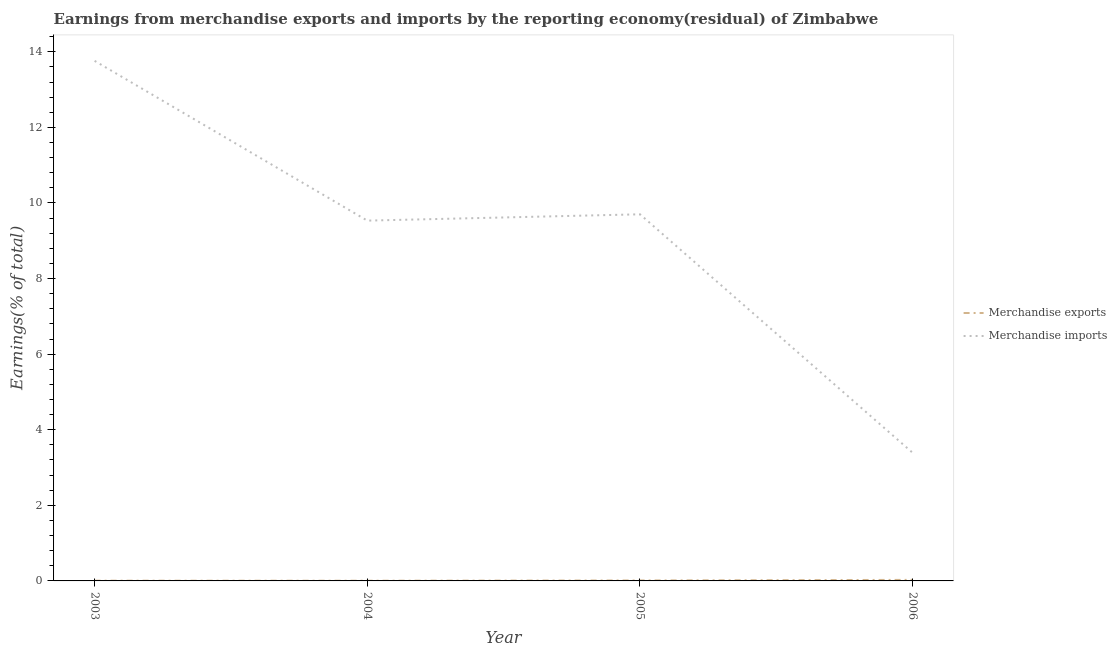How many different coloured lines are there?
Offer a very short reply. 2. Does the line corresponding to earnings from merchandise exports intersect with the line corresponding to earnings from merchandise imports?
Make the answer very short. No. Is the number of lines equal to the number of legend labels?
Your answer should be compact. Yes. What is the earnings from merchandise imports in 2005?
Give a very brief answer. 9.7. Across all years, what is the maximum earnings from merchandise exports?
Offer a very short reply. 0.03. Across all years, what is the minimum earnings from merchandise imports?
Offer a very short reply. 3.39. In which year was the earnings from merchandise imports maximum?
Make the answer very short. 2003. In which year was the earnings from merchandise imports minimum?
Provide a succinct answer. 2006. What is the total earnings from merchandise imports in the graph?
Make the answer very short. 36.38. What is the difference between the earnings from merchandise imports in 2005 and that in 2006?
Your answer should be very brief. 6.31. What is the difference between the earnings from merchandise exports in 2006 and the earnings from merchandise imports in 2005?
Ensure brevity in your answer.  -9.67. What is the average earnings from merchandise imports per year?
Offer a very short reply. 9.1. In the year 2005, what is the difference between the earnings from merchandise exports and earnings from merchandise imports?
Provide a short and direct response. -9.69. In how many years, is the earnings from merchandise exports greater than 4.8 %?
Give a very brief answer. 0. What is the ratio of the earnings from merchandise exports in 2005 to that in 2006?
Ensure brevity in your answer.  0.44. Is the earnings from merchandise exports in 2005 less than that in 2006?
Give a very brief answer. Yes. Is the difference between the earnings from merchandise exports in 2003 and 2006 greater than the difference between the earnings from merchandise imports in 2003 and 2006?
Your answer should be compact. No. What is the difference between the highest and the second highest earnings from merchandise imports?
Your answer should be compact. 4.06. What is the difference between the highest and the lowest earnings from merchandise exports?
Provide a succinct answer. 0.02. Is the sum of the earnings from merchandise exports in 2003 and 2006 greater than the maximum earnings from merchandise imports across all years?
Offer a very short reply. No. Does the earnings from merchandise exports monotonically increase over the years?
Ensure brevity in your answer.  No. Is the earnings from merchandise imports strictly greater than the earnings from merchandise exports over the years?
Keep it short and to the point. Yes. Is the earnings from merchandise exports strictly less than the earnings from merchandise imports over the years?
Your answer should be compact. Yes. What is the difference between two consecutive major ticks on the Y-axis?
Provide a short and direct response. 2. Are the values on the major ticks of Y-axis written in scientific E-notation?
Your response must be concise. No. Does the graph contain grids?
Your response must be concise. No. Where does the legend appear in the graph?
Your response must be concise. Center right. How are the legend labels stacked?
Offer a very short reply. Vertical. What is the title of the graph?
Give a very brief answer. Earnings from merchandise exports and imports by the reporting economy(residual) of Zimbabwe. Does "Unregistered firms" appear as one of the legend labels in the graph?
Your answer should be compact. No. What is the label or title of the Y-axis?
Your answer should be very brief. Earnings(% of total). What is the Earnings(% of total) of Merchandise exports in 2003?
Give a very brief answer. 0.01. What is the Earnings(% of total) in Merchandise imports in 2003?
Provide a succinct answer. 13.76. What is the Earnings(% of total) in Merchandise exports in 2004?
Ensure brevity in your answer.  0.01. What is the Earnings(% of total) of Merchandise imports in 2004?
Give a very brief answer. 9.53. What is the Earnings(% of total) in Merchandise exports in 2005?
Your answer should be very brief. 0.01. What is the Earnings(% of total) of Merchandise imports in 2005?
Provide a short and direct response. 9.7. What is the Earnings(% of total) of Merchandise exports in 2006?
Your answer should be very brief. 0.03. What is the Earnings(% of total) of Merchandise imports in 2006?
Your answer should be very brief. 3.39. Across all years, what is the maximum Earnings(% of total) in Merchandise exports?
Provide a short and direct response. 0.03. Across all years, what is the maximum Earnings(% of total) of Merchandise imports?
Give a very brief answer. 13.76. Across all years, what is the minimum Earnings(% of total) of Merchandise exports?
Make the answer very short. 0.01. Across all years, what is the minimum Earnings(% of total) of Merchandise imports?
Offer a terse response. 3.39. What is the total Earnings(% of total) of Merchandise exports in the graph?
Your response must be concise. 0.05. What is the total Earnings(% of total) of Merchandise imports in the graph?
Make the answer very short. 36.38. What is the difference between the Earnings(% of total) of Merchandise exports in 2003 and that in 2004?
Offer a very short reply. 0. What is the difference between the Earnings(% of total) of Merchandise imports in 2003 and that in 2004?
Keep it short and to the point. 4.23. What is the difference between the Earnings(% of total) in Merchandise exports in 2003 and that in 2005?
Offer a very short reply. -0.01. What is the difference between the Earnings(% of total) of Merchandise imports in 2003 and that in 2005?
Keep it short and to the point. 4.06. What is the difference between the Earnings(% of total) of Merchandise exports in 2003 and that in 2006?
Your response must be concise. -0.02. What is the difference between the Earnings(% of total) of Merchandise imports in 2003 and that in 2006?
Your answer should be compact. 10.37. What is the difference between the Earnings(% of total) of Merchandise exports in 2004 and that in 2005?
Ensure brevity in your answer.  -0.01. What is the difference between the Earnings(% of total) in Merchandise imports in 2004 and that in 2005?
Provide a short and direct response. -0.17. What is the difference between the Earnings(% of total) of Merchandise exports in 2004 and that in 2006?
Your answer should be very brief. -0.02. What is the difference between the Earnings(% of total) in Merchandise imports in 2004 and that in 2006?
Your answer should be compact. 6.14. What is the difference between the Earnings(% of total) of Merchandise exports in 2005 and that in 2006?
Your response must be concise. -0.02. What is the difference between the Earnings(% of total) in Merchandise imports in 2005 and that in 2006?
Provide a short and direct response. 6.31. What is the difference between the Earnings(% of total) of Merchandise exports in 2003 and the Earnings(% of total) of Merchandise imports in 2004?
Offer a terse response. -9.53. What is the difference between the Earnings(% of total) of Merchandise exports in 2003 and the Earnings(% of total) of Merchandise imports in 2005?
Make the answer very short. -9.69. What is the difference between the Earnings(% of total) of Merchandise exports in 2003 and the Earnings(% of total) of Merchandise imports in 2006?
Make the answer very short. -3.38. What is the difference between the Earnings(% of total) in Merchandise exports in 2004 and the Earnings(% of total) in Merchandise imports in 2005?
Ensure brevity in your answer.  -9.69. What is the difference between the Earnings(% of total) in Merchandise exports in 2004 and the Earnings(% of total) in Merchandise imports in 2006?
Provide a succinct answer. -3.38. What is the difference between the Earnings(% of total) in Merchandise exports in 2005 and the Earnings(% of total) in Merchandise imports in 2006?
Provide a succinct answer. -3.38. What is the average Earnings(% of total) in Merchandise exports per year?
Your answer should be compact. 0.01. What is the average Earnings(% of total) in Merchandise imports per year?
Provide a short and direct response. 9.1. In the year 2003, what is the difference between the Earnings(% of total) in Merchandise exports and Earnings(% of total) in Merchandise imports?
Offer a terse response. -13.75. In the year 2004, what is the difference between the Earnings(% of total) in Merchandise exports and Earnings(% of total) in Merchandise imports?
Your answer should be compact. -9.53. In the year 2005, what is the difference between the Earnings(% of total) of Merchandise exports and Earnings(% of total) of Merchandise imports?
Ensure brevity in your answer.  -9.69. In the year 2006, what is the difference between the Earnings(% of total) of Merchandise exports and Earnings(% of total) of Merchandise imports?
Make the answer very short. -3.36. What is the ratio of the Earnings(% of total) in Merchandise exports in 2003 to that in 2004?
Make the answer very short. 1.17. What is the ratio of the Earnings(% of total) in Merchandise imports in 2003 to that in 2004?
Ensure brevity in your answer.  1.44. What is the ratio of the Earnings(% of total) in Merchandise exports in 2003 to that in 2005?
Provide a succinct answer. 0.51. What is the ratio of the Earnings(% of total) of Merchandise imports in 2003 to that in 2005?
Keep it short and to the point. 1.42. What is the ratio of the Earnings(% of total) in Merchandise exports in 2003 to that in 2006?
Provide a succinct answer. 0.23. What is the ratio of the Earnings(% of total) of Merchandise imports in 2003 to that in 2006?
Your response must be concise. 4.06. What is the ratio of the Earnings(% of total) in Merchandise exports in 2004 to that in 2005?
Provide a short and direct response. 0.44. What is the ratio of the Earnings(% of total) of Merchandise imports in 2004 to that in 2005?
Keep it short and to the point. 0.98. What is the ratio of the Earnings(% of total) of Merchandise exports in 2004 to that in 2006?
Your answer should be very brief. 0.19. What is the ratio of the Earnings(% of total) of Merchandise imports in 2004 to that in 2006?
Provide a succinct answer. 2.81. What is the ratio of the Earnings(% of total) in Merchandise exports in 2005 to that in 2006?
Your answer should be very brief. 0.44. What is the ratio of the Earnings(% of total) of Merchandise imports in 2005 to that in 2006?
Offer a terse response. 2.86. What is the difference between the highest and the second highest Earnings(% of total) in Merchandise exports?
Your answer should be very brief. 0.02. What is the difference between the highest and the second highest Earnings(% of total) of Merchandise imports?
Your response must be concise. 4.06. What is the difference between the highest and the lowest Earnings(% of total) in Merchandise exports?
Your answer should be compact. 0.02. What is the difference between the highest and the lowest Earnings(% of total) in Merchandise imports?
Provide a succinct answer. 10.37. 